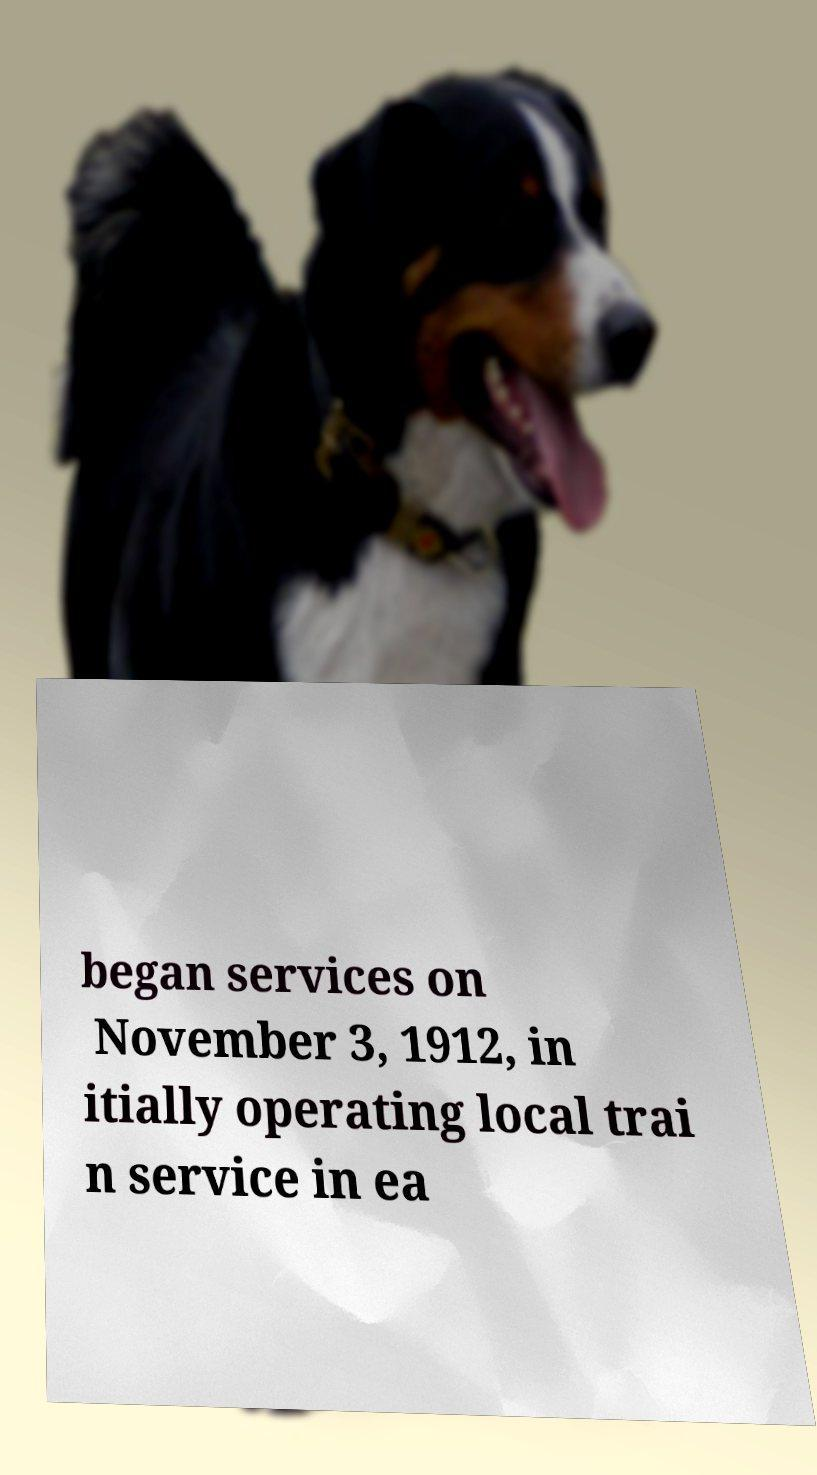Can you accurately transcribe the text from the provided image for me? began services on November 3, 1912, in itially operating local trai n service in ea 